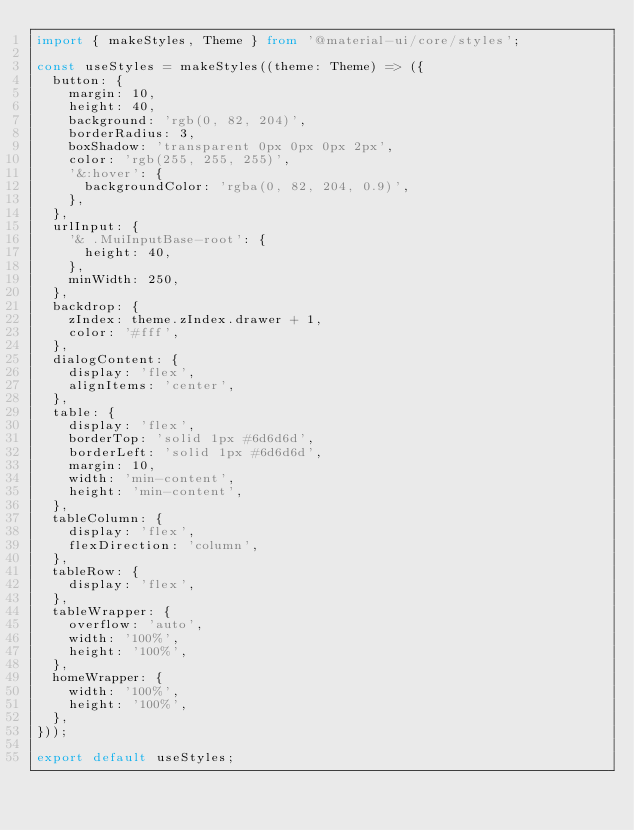<code> <loc_0><loc_0><loc_500><loc_500><_TypeScript_>import { makeStyles, Theme } from '@material-ui/core/styles';

const useStyles = makeStyles((theme: Theme) => ({
  button: {
    margin: 10,
    height: 40,
    background: 'rgb(0, 82, 204)',
    borderRadius: 3,
    boxShadow: 'transparent 0px 0px 0px 2px',
    color: 'rgb(255, 255, 255)',
    '&:hover': {
      backgroundColor: 'rgba(0, 82, 204, 0.9)',
    },
  },
  urlInput: {
    '& .MuiInputBase-root': {
      height: 40,
    },
    minWidth: 250,
  },
  backdrop: {
    zIndex: theme.zIndex.drawer + 1,
    color: '#fff',
  },
  dialogContent: {
    display: 'flex',
    alignItems: 'center',
  },
  table: {
    display: 'flex',
    borderTop: 'solid 1px #6d6d6d',
    borderLeft: 'solid 1px #6d6d6d',
    margin: 10,
    width: 'min-content',
    height: 'min-content',
  },
  tableColumn: {
    display: 'flex',
    flexDirection: 'column',
  },
  tableRow: {
    display: 'flex',
  },
  tableWrapper: {
    overflow: 'auto',
    width: '100%',
    height: '100%',
  },
  homeWrapper: {
    width: '100%',
    height: '100%',
  },
}));

export default useStyles;
</code> 